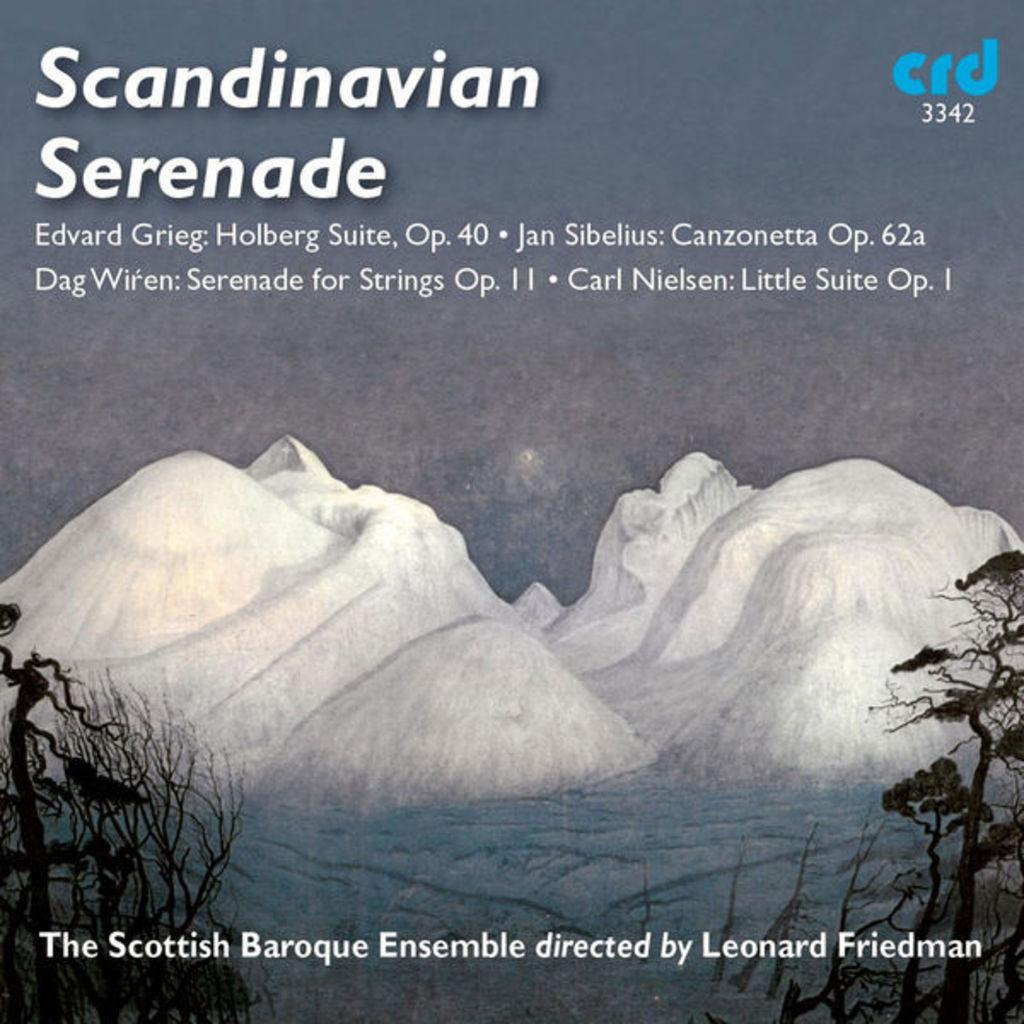What is hanging in the image? There is a banner in the image. What is written on the banner? There is writing on the banner. What type of landscape can be seen in the image? Hills, water, and trees are visible in the image. What type of ball is being used to collect quartz in the image? There is no ball or quartz present in the image. 